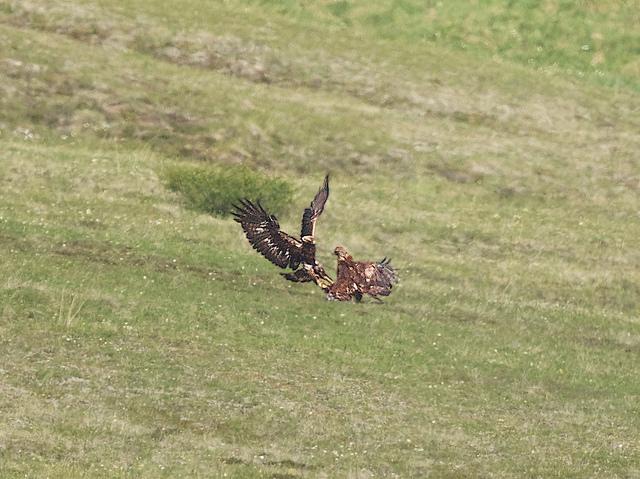How many types of animals are there?
Keep it brief. 1. Are these birds fighting?
Concise answer only. Yes. Is there a shrub in this picture?
Be succinct. Yes. How many birds are in this picture?
Be succinct. 2. 